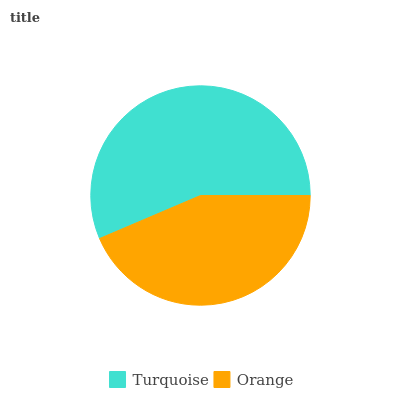Is Orange the minimum?
Answer yes or no. Yes. Is Turquoise the maximum?
Answer yes or no. Yes. Is Orange the maximum?
Answer yes or no. No. Is Turquoise greater than Orange?
Answer yes or no. Yes. Is Orange less than Turquoise?
Answer yes or no. Yes. Is Orange greater than Turquoise?
Answer yes or no. No. Is Turquoise less than Orange?
Answer yes or no. No. Is Turquoise the high median?
Answer yes or no. Yes. Is Orange the low median?
Answer yes or no. Yes. Is Orange the high median?
Answer yes or no. No. Is Turquoise the low median?
Answer yes or no. No. 